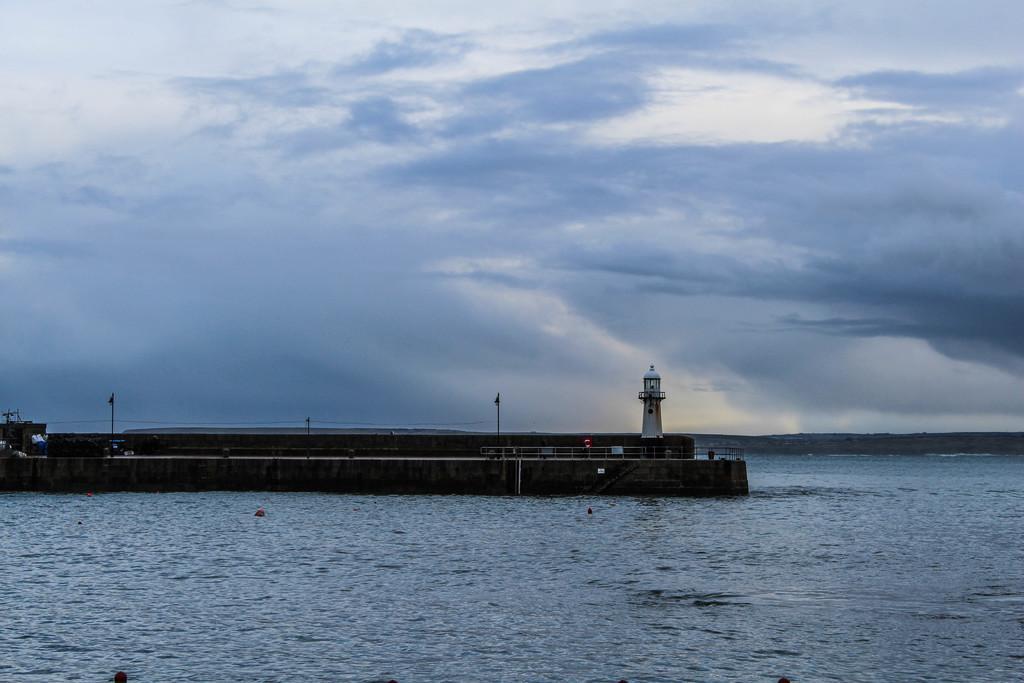Describe this image in one or two sentences. In this image I can see the water. In the background I can see the lighthouse, few poles and the railing and the sky is in blue and white color. 